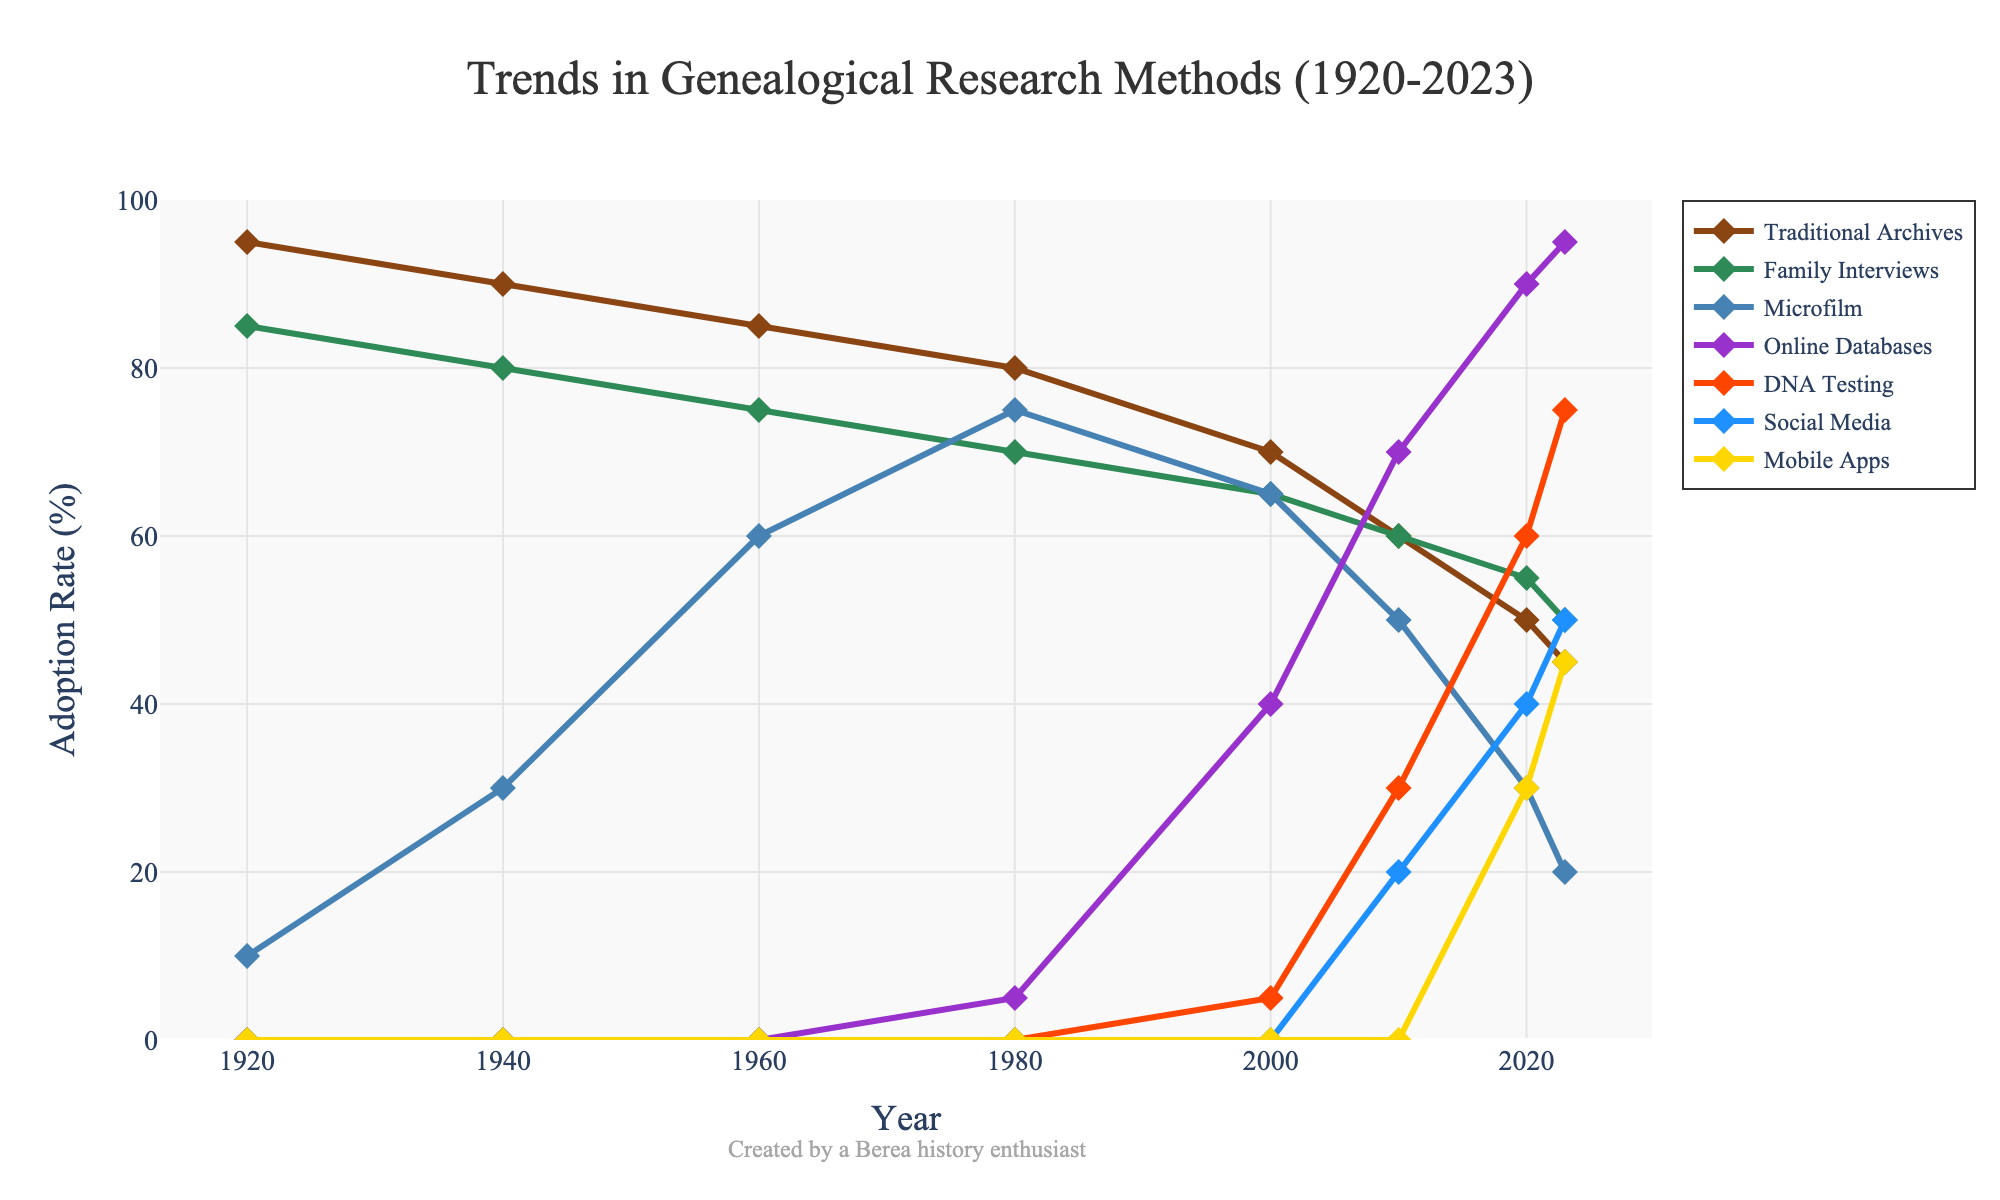What's the trend in the adoption rate of traditional archives from 1920 to 2023? The graph shows that the adoption rate of traditional archives decreases from 95% in 1920 to 45% in 2023. This indicates a steady decline over time.
Answer: Decreasing In what year did online databases surpass family interviews in adoption rate? We need to identify the year when the line for online databases goes above the line for family interviews. According to the graph, this happened around 2010 when online databases reached 70% while family interviews were at 60%.
Answer: 2010 Which research method has shown the greatest increase in adoption rate from 2000 to 2023? To find the greatest increase, compare the difference in adoption rates from 2000 to 2023 for each method. DNA testing increased from 5% to 75% (70%), which is the largest increase among all methods.
Answer: DNA testing How do the adoption rates of social media and mobile apps compare in 2023? In 2023, the adoption rate of social media is 50%, and the adoption rate of mobile apps is 45%. By comparing these values, we see that social media has a higher adoption rate than mobile apps.
Answer: Social Media is higher By how much did the adoption rate of microfilm change from 1960 to 2020? The adoption rate of microfilm decreased from 60% in 1960 to 30% in 2020. The change is calculated as 60% - 30% = 30%.
Answer: 30% What is the average adoption rate of family interviews from 1920 to 2020? To find the average adoption rate, sum the rates for family interviews over the years and divide by the number of years: (85+80+75+70+65+60+55) / 7 = 490 / 7 = 70%.
Answer: 70% Which method had the lowest adoption rate in any given year, and what year was it? The graph shows that DNA testing had the lowest adoption rate in 1920, 1940, 1960, and 1980 with 0%. Since multiple years have this same rate, choose the first instance, which is 1920.
Answer: DNA testing in 1920 How did the adoption rates of family interviews and traditional archives compare in 1920 and 2023? In 1920, the adoption rate for family interviews was 85%, and for traditional archives, it was 95%. In 2023, the adoption rate for family interviews was 50%, and for traditional archives, it was 45%. Family interviews started lower but ended higher than traditional archives.
Answer: Family interviews were lower in 1920 and higher in 2023 What color represents the online databases in the figure? By examining the visual attributes of the lines, the online databases are represented by the line colored in purple (or a similar shade).
Answer: Purple Did the adoption rate of mobile apps ever surpass that of microfilm? Looking at the graph, mobile apps and microfilm never intersect, and mobile apps' adoption rate always remains below microfilm's rate throughout the years until 2023.
Answer: No 